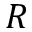<formula> <loc_0><loc_0><loc_500><loc_500>R</formula> 